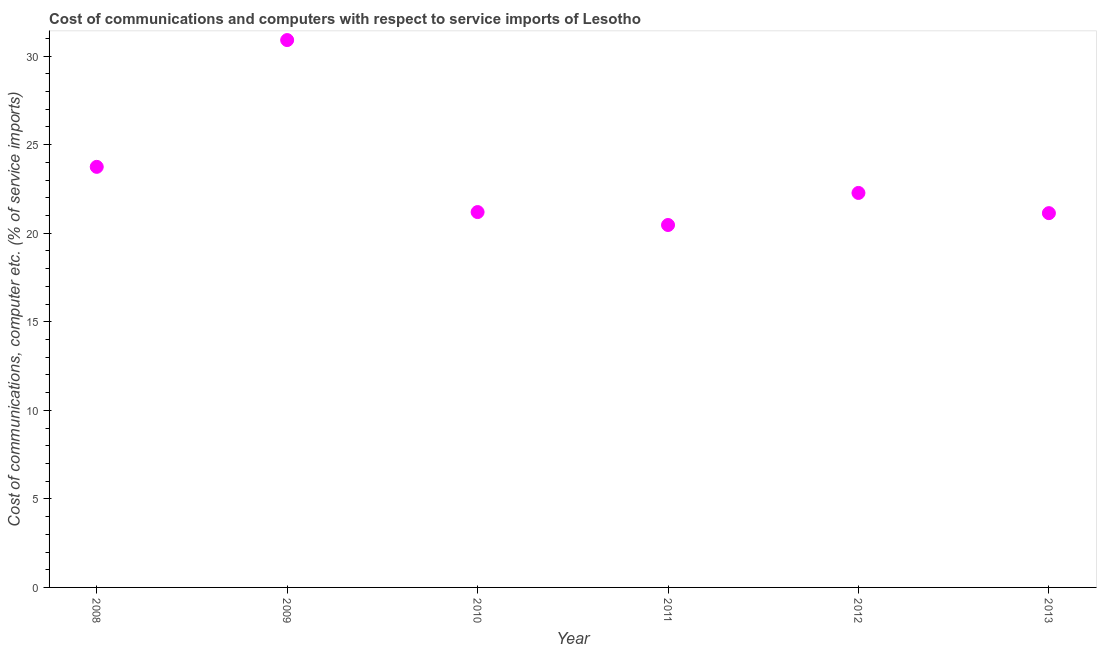What is the cost of communications and computer in 2009?
Ensure brevity in your answer.  30.9. Across all years, what is the maximum cost of communications and computer?
Your answer should be very brief. 30.9. Across all years, what is the minimum cost of communications and computer?
Provide a short and direct response. 20.46. What is the sum of the cost of communications and computer?
Provide a short and direct response. 139.7. What is the difference between the cost of communications and computer in 2009 and 2013?
Make the answer very short. 9.77. What is the average cost of communications and computer per year?
Provide a short and direct response. 23.28. What is the median cost of communications and computer?
Your answer should be compact. 21.73. In how many years, is the cost of communications and computer greater than 15 %?
Give a very brief answer. 6. Do a majority of the years between 2010 and 2008 (inclusive) have cost of communications and computer greater than 7 %?
Ensure brevity in your answer.  No. What is the ratio of the cost of communications and computer in 2009 to that in 2010?
Offer a terse response. 1.46. What is the difference between the highest and the second highest cost of communications and computer?
Offer a very short reply. 7.16. What is the difference between the highest and the lowest cost of communications and computer?
Keep it short and to the point. 10.44. In how many years, is the cost of communications and computer greater than the average cost of communications and computer taken over all years?
Your response must be concise. 2. Does the cost of communications and computer monotonically increase over the years?
Offer a terse response. No. Are the values on the major ticks of Y-axis written in scientific E-notation?
Provide a short and direct response. No. What is the title of the graph?
Your answer should be very brief. Cost of communications and computers with respect to service imports of Lesotho. What is the label or title of the Y-axis?
Your answer should be compact. Cost of communications, computer etc. (% of service imports). What is the Cost of communications, computer etc. (% of service imports) in 2008?
Offer a very short reply. 23.74. What is the Cost of communications, computer etc. (% of service imports) in 2009?
Provide a short and direct response. 30.9. What is the Cost of communications, computer etc. (% of service imports) in 2010?
Keep it short and to the point. 21.19. What is the Cost of communications, computer etc. (% of service imports) in 2011?
Offer a terse response. 20.46. What is the Cost of communications, computer etc. (% of service imports) in 2012?
Provide a succinct answer. 22.27. What is the Cost of communications, computer etc. (% of service imports) in 2013?
Your answer should be very brief. 21.13. What is the difference between the Cost of communications, computer etc. (% of service imports) in 2008 and 2009?
Your answer should be compact. -7.16. What is the difference between the Cost of communications, computer etc. (% of service imports) in 2008 and 2010?
Your response must be concise. 2.55. What is the difference between the Cost of communications, computer etc. (% of service imports) in 2008 and 2011?
Give a very brief answer. 3.28. What is the difference between the Cost of communications, computer etc. (% of service imports) in 2008 and 2012?
Give a very brief answer. 1.47. What is the difference between the Cost of communications, computer etc. (% of service imports) in 2008 and 2013?
Give a very brief answer. 2.61. What is the difference between the Cost of communications, computer etc. (% of service imports) in 2009 and 2010?
Offer a terse response. 9.71. What is the difference between the Cost of communications, computer etc. (% of service imports) in 2009 and 2011?
Offer a very short reply. 10.44. What is the difference between the Cost of communications, computer etc. (% of service imports) in 2009 and 2012?
Provide a succinct answer. 8.63. What is the difference between the Cost of communications, computer etc. (% of service imports) in 2009 and 2013?
Your response must be concise. 9.77. What is the difference between the Cost of communications, computer etc. (% of service imports) in 2010 and 2011?
Keep it short and to the point. 0.73. What is the difference between the Cost of communications, computer etc. (% of service imports) in 2010 and 2012?
Offer a terse response. -1.08. What is the difference between the Cost of communications, computer etc. (% of service imports) in 2010 and 2013?
Provide a short and direct response. 0.06. What is the difference between the Cost of communications, computer etc. (% of service imports) in 2011 and 2012?
Provide a succinct answer. -1.81. What is the difference between the Cost of communications, computer etc. (% of service imports) in 2011 and 2013?
Ensure brevity in your answer.  -0.67. What is the difference between the Cost of communications, computer etc. (% of service imports) in 2012 and 2013?
Offer a very short reply. 1.14. What is the ratio of the Cost of communications, computer etc. (% of service imports) in 2008 to that in 2009?
Provide a succinct answer. 0.77. What is the ratio of the Cost of communications, computer etc. (% of service imports) in 2008 to that in 2010?
Offer a very short reply. 1.12. What is the ratio of the Cost of communications, computer etc. (% of service imports) in 2008 to that in 2011?
Ensure brevity in your answer.  1.16. What is the ratio of the Cost of communications, computer etc. (% of service imports) in 2008 to that in 2012?
Your response must be concise. 1.07. What is the ratio of the Cost of communications, computer etc. (% of service imports) in 2008 to that in 2013?
Offer a very short reply. 1.12. What is the ratio of the Cost of communications, computer etc. (% of service imports) in 2009 to that in 2010?
Offer a very short reply. 1.46. What is the ratio of the Cost of communications, computer etc. (% of service imports) in 2009 to that in 2011?
Your response must be concise. 1.51. What is the ratio of the Cost of communications, computer etc. (% of service imports) in 2009 to that in 2012?
Offer a very short reply. 1.39. What is the ratio of the Cost of communications, computer etc. (% of service imports) in 2009 to that in 2013?
Keep it short and to the point. 1.46. What is the ratio of the Cost of communications, computer etc. (% of service imports) in 2010 to that in 2011?
Ensure brevity in your answer.  1.04. What is the ratio of the Cost of communications, computer etc. (% of service imports) in 2010 to that in 2012?
Make the answer very short. 0.95. What is the ratio of the Cost of communications, computer etc. (% of service imports) in 2010 to that in 2013?
Provide a succinct answer. 1. What is the ratio of the Cost of communications, computer etc. (% of service imports) in 2011 to that in 2012?
Ensure brevity in your answer.  0.92. What is the ratio of the Cost of communications, computer etc. (% of service imports) in 2011 to that in 2013?
Provide a succinct answer. 0.97. What is the ratio of the Cost of communications, computer etc. (% of service imports) in 2012 to that in 2013?
Provide a succinct answer. 1.05. 